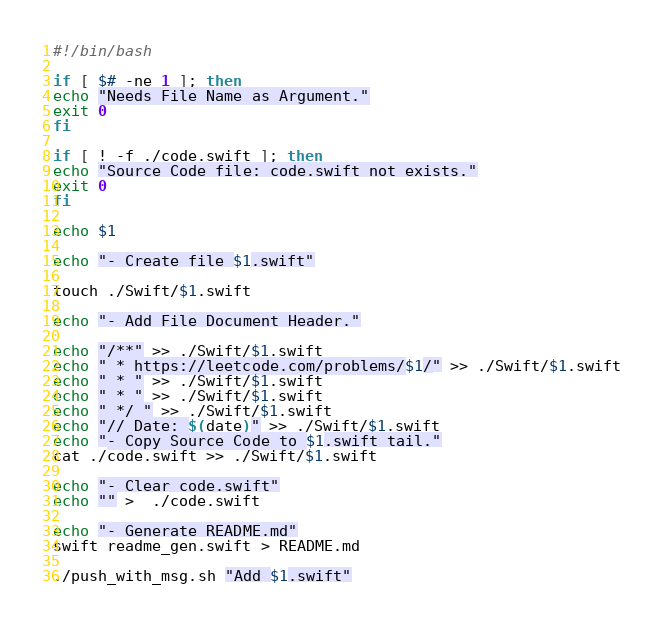<code> <loc_0><loc_0><loc_500><loc_500><_Bash_>#!/bin/bash

if [ $# -ne 1 ]; then
echo "Needs File Name as Argument."
exit 0
fi

if [ ! -f ./code.swift ]; then
echo "Source Code file: code.swift not exists."
exit 0
fi

echo $1

echo "- Create file $1.swift"

touch ./Swift/$1.swift

echo "- Add File Document Header."

echo "/**" >> ./Swift/$1.swift
echo " * https://leetcode.com/problems/$1/" >> ./Swift/$1.swift
echo " * " >> ./Swift/$1.swift
echo " * " >> ./Swift/$1.swift
echo " */ " >> ./Swift/$1.swift
echo "// Date: $(date)" >> ./Swift/$1.swift
echo "- Copy Source Code to $1.swift tail."
cat ./code.swift >> ./Swift/$1.swift

echo "- Clear code.swift"
echo "" >  ./code.swift

echo "- Generate README.md"
swift readme_gen.swift > README.md

./push_with_msg.sh "Add $1.swift"
</code> 